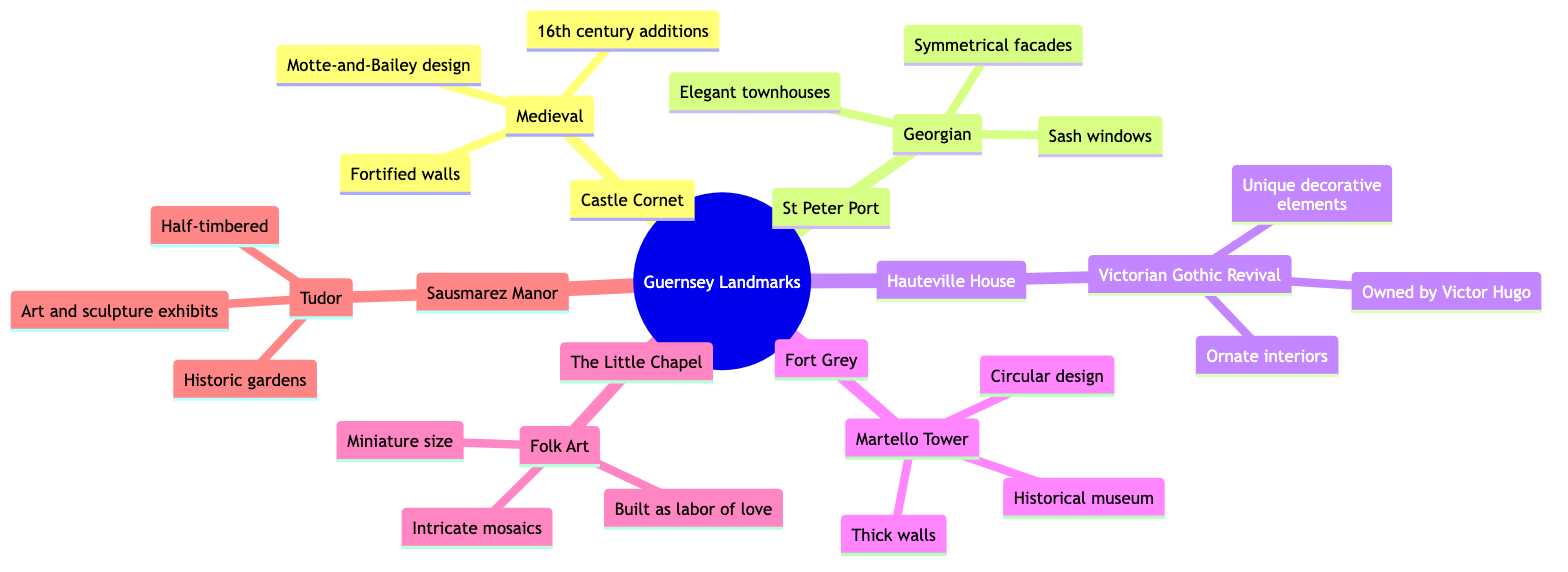What is the architectural style of Castle Cornet? The diagram specifies that Castle Cornet is categorized under the "Medieval" architectural style. This information is directly linked to the node representing Castle Cornet.
Answer: Medieval How many key features are listed for St Peter Port? The diagram indicates that there are three key features listed for St Peter Port, as seen under its corresponding node in the mind map.
Answer: 3 Which landmark is known for its intricate mosaics? The Little Chapel is identified in the diagram as having key features that include "intricate mosaics." This is derived from the specific node detailing The Little Chapel.
Answer: The Little Chapel What are the key features of Sausmarez Manor? The diagram highlights three key features associated with Sausmarez Manor: "Half-timbered," "Historic gardens," and "Art and sculpture exhibits." These features are grouped under the specific node for Sausmarez Manor.
Answer: Half-timbered, Historic gardens, Art and sculpture exhibits Which architectural style is represented by Fort Grey? Fort Grey is indicated in the diagram as a Martello Tower, which is its architectural style. This is directly referenced from the node relating to Fort Grey.
Answer: Martello Tower How does the architectural style of Hauteville House differ from that of Castle Cornet? The architectural style of Hauteville House is "Victorian Gothic Revival," while Castle Cornet's style is "Medieval." This requires the comparison of the two nodes from the mind map, showing the different styles for each landmark.
Answer: Different styles What landmark was owned by Victor Hugo? The diagram states that Hauteville House was owned by Victor Hugo, indicated in the key features of the Hauteville House node.
Answer: Hauteville House Which landmarks feature fortified walls as a key feature? According to the diagram, only Castle Cornet lists "fortified walls" as a key feature. This can be identified by examining the key features under each landmark's node.
Answer: Castle Cornet 